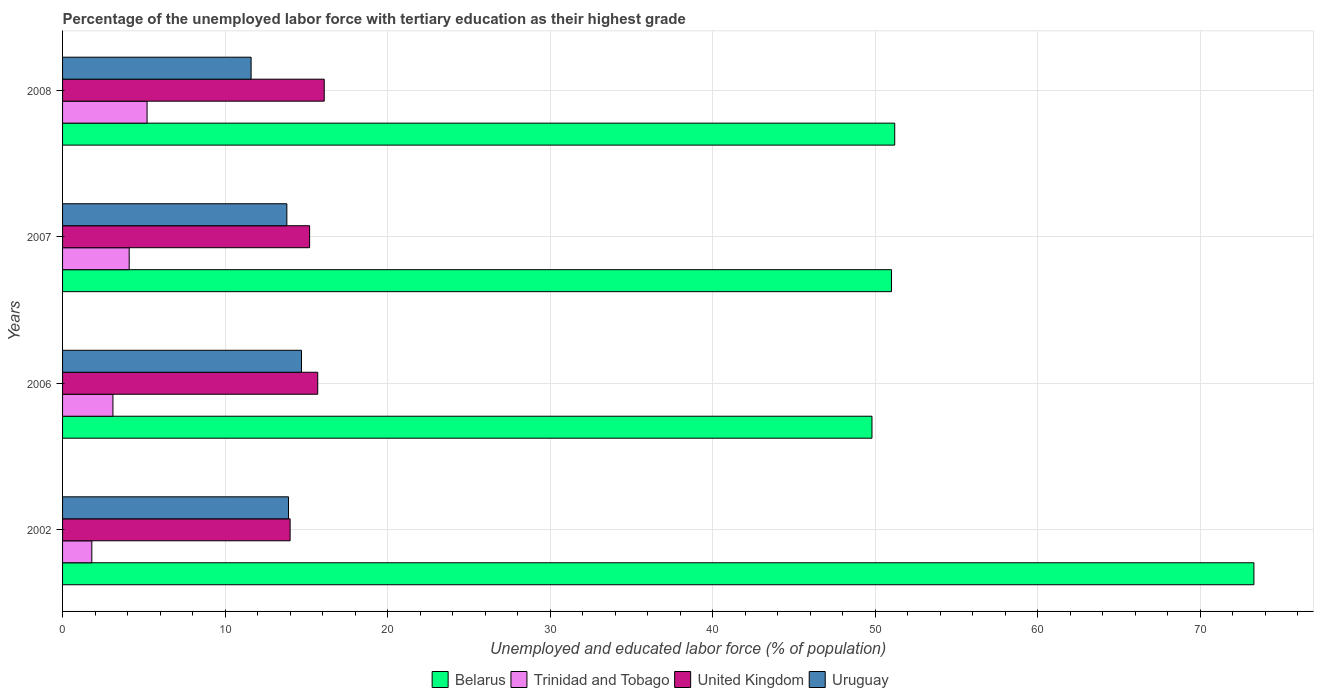How many groups of bars are there?
Give a very brief answer. 4. Are the number of bars on each tick of the Y-axis equal?
Offer a very short reply. Yes. What is the label of the 4th group of bars from the top?
Offer a very short reply. 2002. In how many cases, is the number of bars for a given year not equal to the number of legend labels?
Offer a very short reply. 0. What is the percentage of the unemployed labor force with tertiary education in Uruguay in 2008?
Provide a succinct answer. 11.6. Across all years, what is the maximum percentage of the unemployed labor force with tertiary education in Uruguay?
Provide a succinct answer. 14.7. Across all years, what is the minimum percentage of the unemployed labor force with tertiary education in Uruguay?
Offer a very short reply. 11.6. In which year was the percentage of the unemployed labor force with tertiary education in Trinidad and Tobago minimum?
Offer a terse response. 2002. What is the total percentage of the unemployed labor force with tertiary education in Belarus in the graph?
Provide a short and direct response. 225.3. What is the difference between the percentage of the unemployed labor force with tertiary education in Belarus in 2006 and that in 2007?
Make the answer very short. -1.2. What is the difference between the percentage of the unemployed labor force with tertiary education in Uruguay in 2006 and the percentage of the unemployed labor force with tertiary education in United Kingdom in 2007?
Offer a very short reply. -0.5. What is the average percentage of the unemployed labor force with tertiary education in Trinidad and Tobago per year?
Provide a short and direct response. 3.55. In the year 2008, what is the difference between the percentage of the unemployed labor force with tertiary education in Trinidad and Tobago and percentage of the unemployed labor force with tertiary education in Uruguay?
Offer a very short reply. -6.4. What is the ratio of the percentage of the unemployed labor force with tertiary education in Uruguay in 2002 to that in 2007?
Give a very brief answer. 1.01. Is the percentage of the unemployed labor force with tertiary education in Uruguay in 2007 less than that in 2008?
Keep it short and to the point. No. What is the difference between the highest and the second highest percentage of the unemployed labor force with tertiary education in United Kingdom?
Offer a terse response. 0.4. What is the difference between the highest and the lowest percentage of the unemployed labor force with tertiary education in Trinidad and Tobago?
Offer a very short reply. 3.4. Is it the case that in every year, the sum of the percentage of the unemployed labor force with tertiary education in Trinidad and Tobago and percentage of the unemployed labor force with tertiary education in United Kingdom is greater than the sum of percentage of the unemployed labor force with tertiary education in Belarus and percentage of the unemployed labor force with tertiary education in Uruguay?
Offer a terse response. No. What does the 4th bar from the top in 2007 represents?
Your answer should be very brief. Belarus. What does the 2nd bar from the bottom in 2006 represents?
Ensure brevity in your answer.  Trinidad and Tobago. Is it the case that in every year, the sum of the percentage of the unemployed labor force with tertiary education in Uruguay and percentage of the unemployed labor force with tertiary education in Trinidad and Tobago is greater than the percentage of the unemployed labor force with tertiary education in United Kingdom?
Your answer should be compact. Yes. How many bars are there?
Your answer should be very brief. 16. How many years are there in the graph?
Offer a terse response. 4. What is the difference between two consecutive major ticks on the X-axis?
Offer a terse response. 10. How many legend labels are there?
Offer a terse response. 4. How are the legend labels stacked?
Your response must be concise. Horizontal. What is the title of the graph?
Offer a very short reply. Percentage of the unemployed labor force with tertiary education as their highest grade. What is the label or title of the X-axis?
Your answer should be compact. Unemployed and educated labor force (% of population). What is the Unemployed and educated labor force (% of population) of Belarus in 2002?
Make the answer very short. 73.3. What is the Unemployed and educated labor force (% of population) of Trinidad and Tobago in 2002?
Keep it short and to the point. 1.8. What is the Unemployed and educated labor force (% of population) in Uruguay in 2002?
Your answer should be very brief. 13.9. What is the Unemployed and educated labor force (% of population) of Belarus in 2006?
Make the answer very short. 49.8. What is the Unemployed and educated labor force (% of population) of Trinidad and Tobago in 2006?
Your answer should be very brief. 3.1. What is the Unemployed and educated labor force (% of population) in United Kingdom in 2006?
Provide a succinct answer. 15.7. What is the Unemployed and educated labor force (% of population) of Uruguay in 2006?
Ensure brevity in your answer.  14.7. What is the Unemployed and educated labor force (% of population) of Trinidad and Tobago in 2007?
Ensure brevity in your answer.  4.1. What is the Unemployed and educated labor force (% of population) of United Kingdom in 2007?
Ensure brevity in your answer.  15.2. What is the Unemployed and educated labor force (% of population) of Uruguay in 2007?
Your answer should be compact. 13.8. What is the Unemployed and educated labor force (% of population) in Belarus in 2008?
Provide a short and direct response. 51.2. What is the Unemployed and educated labor force (% of population) in Trinidad and Tobago in 2008?
Offer a terse response. 5.2. What is the Unemployed and educated labor force (% of population) in United Kingdom in 2008?
Ensure brevity in your answer.  16.1. What is the Unemployed and educated labor force (% of population) of Uruguay in 2008?
Your answer should be very brief. 11.6. Across all years, what is the maximum Unemployed and educated labor force (% of population) in Belarus?
Ensure brevity in your answer.  73.3. Across all years, what is the maximum Unemployed and educated labor force (% of population) in Trinidad and Tobago?
Offer a terse response. 5.2. Across all years, what is the maximum Unemployed and educated labor force (% of population) in United Kingdom?
Offer a terse response. 16.1. Across all years, what is the maximum Unemployed and educated labor force (% of population) of Uruguay?
Offer a terse response. 14.7. Across all years, what is the minimum Unemployed and educated labor force (% of population) in Belarus?
Give a very brief answer. 49.8. Across all years, what is the minimum Unemployed and educated labor force (% of population) of Trinidad and Tobago?
Keep it short and to the point. 1.8. Across all years, what is the minimum Unemployed and educated labor force (% of population) in United Kingdom?
Offer a terse response. 14. Across all years, what is the minimum Unemployed and educated labor force (% of population) in Uruguay?
Provide a short and direct response. 11.6. What is the total Unemployed and educated labor force (% of population) of Belarus in the graph?
Your response must be concise. 225.3. What is the total Unemployed and educated labor force (% of population) in Trinidad and Tobago in the graph?
Offer a terse response. 14.2. What is the total Unemployed and educated labor force (% of population) in United Kingdom in the graph?
Offer a terse response. 61. What is the total Unemployed and educated labor force (% of population) of Uruguay in the graph?
Your answer should be compact. 54. What is the difference between the Unemployed and educated labor force (% of population) of Belarus in 2002 and that in 2006?
Provide a short and direct response. 23.5. What is the difference between the Unemployed and educated labor force (% of population) in Trinidad and Tobago in 2002 and that in 2006?
Ensure brevity in your answer.  -1.3. What is the difference between the Unemployed and educated labor force (% of population) of Uruguay in 2002 and that in 2006?
Give a very brief answer. -0.8. What is the difference between the Unemployed and educated labor force (% of population) of Belarus in 2002 and that in 2007?
Offer a terse response. 22.3. What is the difference between the Unemployed and educated labor force (% of population) in United Kingdom in 2002 and that in 2007?
Provide a succinct answer. -1.2. What is the difference between the Unemployed and educated labor force (% of population) of Uruguay in 2002 and that in 2007?
Ensure brevity in your answer.  0.1. What is the difference between the Unemployed and educated labor force (% of population) of Belarus in 2002 and that in 2008?
Provide a short and direct response. 22.1. What is the difference between the Unemployed and educated labor force (% of population) in United Kingdom in 2002 and that in 2008?
Offer a very short reply. -2.1. What is the difference between the Unemployed and educated labor force (% of population) of Uruguay in 2002 and that in 2008?
Provide a short and direct response. 2.3. What is the difference between the Unemployed and educated labor force (% of population) in United Kingdom in 2006 and that in 2007?
Keep it short and to the point. 0.5. What is the difference between the Unemployed and educated labor force (% of population) in Uruguay in 2006 and that in 2007?
Offer a terse response. 0.9. What is the difference between the Unemployed and educated labor force (% of population) of Belarus in 2007 and that in 2008?
Offer a terse response. -0.2. What is the difference between the Unemployed and educated labor force (% of population) in Belarus in 2002 and the Unemployed and educated labor force (% of population) in Trinidad and Tobago in 2006?
Give a very brief answer. 70.2. What is the difference between the Unemployed and educated labor force (% of population) of Belarus in 2002 and the Unemployed and educated labor force (% of population) of United Kingdom in 2006?
Provide a short and direct response. 57.6. What is the difference between the Unemployed and educated labor force (% of population) in Belarus in 2002 and the Unemployed and educated labor force (% of population) in Uruguay in 2006?
Your answer should be very brief. 58.6. What is the difference between the Unemployed and educated labor force (% of population) in Trinidad and Tobago in 2002 and the Unemployed and educated labor force (% of population) in United Kingdom in 2006?
Offer a terse response. -13.9. What is the difference between the Unemployed and educated labor force (% of population) of Trinidad and Tobago in 2002 and the Unemployed and educated labor force (% of population) of Uruguay in 2006?
Your answer should be very brief. -12.9. What is the difference between the Unemployed and educated labor force (% of population) in Belarus in 2002 and the Unemployed and educated labor force (% of population) in Trinidad and Tobago in 2007?
Ensure brevity in your answer.  69.2. What is the difference between the Unemployed and educated labor force (% of population) of Belarus in 2002 and the Unemployed and educated labor force (% of population) of United Kingdom in 2007?
Your answer should be very brief. 58.1. What is the difference between the Unemployed and educated labor force (% of population) in Belarus in 2002 and the Unemployed and educated labor force (% of population) in Uruguay in 2007?
Offer a very short reply. 59.5. What is the difference between the Unemployed and educated labor force (% of population) of Trinidad and Tobago in 2002 and the Unemployed and educated labor force (% of population) of United Kingdom in 2007?
Ensure brevity in your answer.  -13.4. What is the difference between the Unemployed and educated labor force (% of population) in Trinidad and Tobago in 2002 and the Unemployed and educated labor force (% of population) in Uruguay in 2007?
Make the answer very short. -12. What is the difference between the Unemployed and educated labor force (% of population) in Belarus in 2002 and the Unemployed and educated labor force (% of population) in Trinidad and Tobago in 2008?
Make the answer very short. 68.1. What is the difference between the Unemployed and educated labor force (% of population) of Belarus in 2002 and the Unemployed and educated labor force (% of population) of United Kingdom in 2008?
Keep it short and to the point. 57.2. What is the difference between the Unemployed and educated labor force (% of population) of Belarus in 2002 and the Unemployed and educated labor force (% of population) of Uruguay in 2008?
Provide a short and direct response. 61.7. What is the difference between the Unemployed and educated labor force (% of population) in Trinidad and Tobago in 2002 and the Unemployed and educated labor force (% of population) in United Kingdom in 2008?
Offer a terse response. -14.3. What is the difference between the Unemployed and educated labor force (% of population) of Trinidad and Tobago in 2002 and the Unemployed and educated labor force (% of population) of Uruguay in 2008?
Provide a short and direct response. -9.8. What is the difference between the Unemployed and educated labor force (% of population) of United Kingdom in 2002 and the Unemployed and educated labor force (% of population) of Uruguay in 2008?
Provide a succinct answer. 2.4. What is the difference between the Unemployed and educated labor force (% of population) in Belarus in 2006 and the Unemployed and educated labor force (% of population) in Trinidad and Tobago in 2007?
Provide a short and direct response. 45.7. What is the difference between the Unemployed and educated labor force (% of population) in Belarus in 2006 and the Unemployed and educated labor force (% of population) in United Kingdom in 2007?
Your response must be concise. 34.6. What is the difference between the Unemployed and educated labor force (% of population) in Belarus in 2006 and the Unemployed and educated labor force (% of population) in Trinidad and Tobago in 2008?
Make the answer very short. 44.6. What is the difference between the Unemployed and educated labor force (% of population) in Belarus in 2006 and the Unemployed and educated labor force (% of population) in United Kingdom in 2008?
Offer a terse response. 33.7. What is the difference between the Unemployed and educated labor force (% of population) of Belarus in 2006 and the Unemployed and educated labor force (% of population) of Uruguay in 2008?
Keep it short and to the point. 38.2. What is the difference between the Unemployed and educated labor force (% of population) in Trinidad and Tobago in 2006 and the Unemployed and educated labor force (% of population) in United Kingdom in 2008?
Keep it short and to the point. -13. What is the difference between the Unemployed and educated labor force (% of population) of Belarus in 2007 and the Unemployed and educated labor force (% of population) of Trinidad and Tobago in 2008?
Give a very brief answer. 45.8. What is the difference between the Unemployed and educated labor force (% of population) in Belarus in 2007 and the Unemployed and educated labor force (% of population) in United Kingdom in 2008?
Offer a terse response. 34.9. What is the difference between the Unemployed and educated labor force (% of population) of Belarus in 2007 and the Unemployed and educated labor force (% of population) of Uruguay in 2008?
Offer a very short reply. 39.4. What is the difference between the Unemployed and educated labor force (% of population) in United Kingdom in 2007 and the Unemployed and educated labor force (% of population) in Uruguay in 2008?
Make the answer very short. 3.6. What is the average Unemployed and educated labor force (% of population) of Belarus per year?
Offer a terse response. 56.33. What is the average Unemployed and educated labor force (% of population) of Trinidad and Tobago per year?
Keep it short and to the point. 3.55. What is the average Unemployed and educated labor force (% of population) of United Kingdom per year?
Ensure brevity in your answer.  15.25. In the year 2002, what is the difference between the Unemployed and educated labor force (% of population) in Belarus and Unemployed and educated labor force (% of population) in Trinidad and Tobago?
Your answer should be very brief. 71.5. In the year 2002, what is the difference between the Unemployed and educated labor force (% of population) of Belarus and Unemployed and educated labor force (% of population) of United Kingdom?
Provide a succinct answer. 59.3. In the year 2002, what is the difference between the Unemployed and educated labor force (% of population) of Belarus and Unemployed and educated labor force (% of population) of Uruguay?
Make the answer very short. 59.4. In the year 2002, what is the difference between the Unemployed and educated labor force (% of population) of Trinidad and Tobago and Unemployed and educated labor force (% of population) of United Kingdom?
Provide a short and direct response. -12.2. In the year 2002, what is the difference between the Unemployed and educated labor force (% of population) in Trinidad and Tobago and Unemployed and educated labor force (% of population) in Uruguay?
Make the answer very short. -12.1. In the year 2002, what is the difference between the Unemployed and educated labor force (% of population) of United Kingdom and Unemployed and educated labor force (% of population) of Uruguay?
Offer a terse response. 0.1. In the year 2006, what is the difference between the Unemployed and educated labor force (% of population) in Belarus and Unemployed and educated labor force (% of population) in Trinidad and Tobago?
Offer a very short reply. 46.7. In the year 2006, what is the difference between the Unemployed and educated labor force (% of population) in Belarus and Unemployed and educated labor force (% of population) in United Kingdom?
Make the answer very short. 34.1. In the year 2006, what is the difference between the Unemployed and educated labor force (% of population) in Belarus and Unemployed and educated labor force (% of population) in Uruguay?
Offer a very short reply. 35.1. In the year 2006, what is the difference between the Unemployed and educated labor force (% of population) in Trinidad and Tobago and Unemployed and educated labor force (% of population) in Uruguay?
Make the answer very short. -11.6. In the year 2007, what is the difference between the Unemployed and educated labor force (% of population) of Belarus and Unemployed and educated labor force (% of population) of Trinidad and Tobago?
Make the answer very short. 46.9. In the year 2007, what is the difference between the Unemployed and educated labor force (% of population) in Belarus and Unemployed and educated labor force (% of population) in United Kingdom?
Provide a short and direct response. 35.8. In the year 2007, what is the difference between the Unemployed and educated labor force (% of population) in Belarus and Unemployed and educated labor force (% of population) in Uruguay?
Give a very brief answer. 37.2. In the year 2007, what is the difference between the Unemployed and educated labor force (% of population) of Trinidad and Tobago and Unemployed and educated labor force (% of population) of United Kingdom?
Your answer should be very brief. -11.1. In the year 2008, what is the difference between the Unemployed and educated labor force (% of population) of Belarus and Unemployed and educated labor force (% of population) of Trinidad and Tobago?
Your response must be concise. 46. In the year 2008, what is the difference between the Unemployed and educated labor force (% of population) in Belarus and Unemployed and educated labor force (% of population) in United Kingdom?
Keep it short and to the point. 35.1. In the year 2008, what is the difference between the Unemployed and educated labor force (% of population) of Belarus and Unemployed and educated labor force (% of population) of Uruguay?
Offer a very short reply. 39.6. In the year 2008, what is the difference between the Unemployed and educated labor force (% of population) of Trinidad and Tobago and Unemployed and educated labor force (% of population) of Uruguay?
Offer a very short reply. -6.4. In the year 2008, what is the difference between the Unemployed and educated labor force (% of population) in United Kingdom and Unemployed and educated labor force (% of population) in Uruguay?
Offer a terse response. 4.5. What is the ratio of the Unemployed and educated labor force (% of population) of Belarus in 2002 to that in 2006?
Make the answer very short. 1.47. What is the ratio of the Unemployed and educated labor force (% of population) of Trinidad and Tobago in 2002 to that in 2006?
Provide a succinct answer. 0.58. What is the ratio of the Unemployed and educated labor force (% of population) of United Kingdom in 2002 to that in 2006?
Give a very brief answer. 0.89. What is the ratio of the Unemployed and educated labor force (% of population) in Uruguay in 2002 to that in 2006?
Your answer should be compact. 0.95. What is the ratio of the Unemployed and educated labor force (% of population) of Belarus in 2002 to that in 2007?
Ensure brevity in your answer.  1.44. What is the ratio of the Unemployed and educated labor force (% of population) of Trinidad and Tobago in 2002 to that in 2007?
Your response must be concise. 0.44. What is the ratio of the Unemployed and educated labor force (% of population) in United Kingdom in 2002 to that in 2007?
Your answer should be compact. 0.92. What is the ratio of the Unemployed and educated labor force (% of population) of Uruguay in 2002 to that in 2007?
Your answer should be very brief. 1.01. What is the ratio of the Unemployed and educated labor force (% of population) in Belarus in 2002 to that in 2008?
Keep it short and to the point. 1.43. What is the ratio of the Unemployed and educated labor force (% of population) in Trinidad and Tobago in 2002 to that in 2008?
Keep it short and to the point. 0.35. What is the ratio of the Unemployed and educated labor force (% of population) of United Kingdom in 2002 to that in 2008?
Keep it short and to the point. 0.87. What is the ratio of the Unemployed and educated labor force (% of population) of Uruguay in 2002 to that in 2008?
Offer a terse response. 1.2. What is the ratio of the Unemployed and educated labor force (% of population) of Belarus in 2006 to that in 2007?
Your answer should be compact. 0.98. What is the ratio of the Unemployed and educated labor force (% of population) in Trinidad and Tobago in 2006 to that in 2007?
Provide a short and direct response. 0.76. What is the ratio of the Unemployed and educated labor force (% of population) in United Kingdom in 2006 to that in 2007?
Make the answer very short. 1.03. What is the ratio of the Unemployed and educated labor force (% of population) in Uruguay in 2006 to that in 2007?
Your answer should be very brief. 1.07. What is the ratio of the Unemployed and educated labor force (% of population) in Belarus in 2006 to that in 2008?
Ensure brevity in your answer.  0.97. What is the ratio of the Unemployed and educated labor force (% of population) of Trinidad and Tobago in 2006 to that in 2008?
Provide a short and direct response. 0.6. What is the ratio of the Unemployed and educated labor force (% of population) of United Kingdom in 2006 to that in 2008?
Provide a succinct answer. 0.98. What is the ratio of the Unemployed and educated labor force (% of population) in Uruguay in 2006 to that in 2008?
Your answer should be very brief. 1.27. What is the ratio of the Unemployed and educated labor force (% of population) in Trinidad and Tobago in 2007 to that in 2008?
Your response must be concise. 0.79. What is the ratio of the Unemployed and educated labor force (% of population) in United Kingdom in 2007 to that in 2008?
Your answer should be compact. 0.94. What is the ratio of the Unemployed and educated labor force (% of population) in Uruguay in 2007 to that in 2008?
Give a very brief answer. 1.19. What is the difference between the highest and the second highest Unemployed and educated labor force (% of population) of Belarus?
Your answer should be very brief. 22.1. What is the difference between the highest and the second highest Unemployed and educated labor force (% of population) in Uruguay?
Provide a succinct answer. 0.8. What is the difference between the highest and the lowest Unemployed and educated labor force (% of population) in Belarus?
Provide a succinct answer. 23.5. What is the difference between the highest and the lowest Unemployed and educated labor force (% of population) in Uruguay?
Your response must be concise. 3.1. 